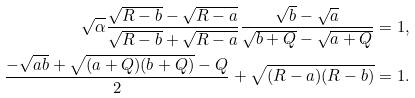Convert formula to latex. <formula><loc_0><loc_0><loc_500><loc_500>\sqrt { \alpha } \frac { \sqrt { R - b } - \sqrt { R - a } } { \sqrt { R - b } + \sqrt { R - a } } \frac { \sqrt { b } - \sqrt { a } } { \sqrt { b + Q } - \sqrt { a + Q } } & = 1 , \\ \frac { - \sqrt { a b } + \sqrt { ( a + Q ) ( b + Q ) } - Q } { 2 } + \sqrt { ( R - a ) ( R - b ) } & = 1 .</formula> 